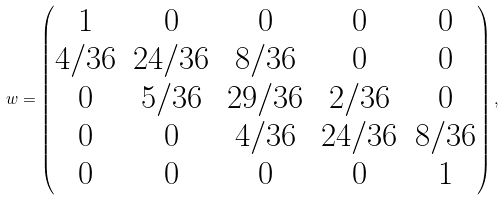<formula> <loc_0><loc_0><loc_500><loc_500>w = \begin{pmatrix} 1 & 0 & 0 & 0 & 0 \\ 4 / 3 6 & 2 4 / 3 6 & 8 / 3 6 & 0 & 0 \\ 0 & 5 / 3 6 & 2 9 / 3 6 & 2 / 3 6 & 0 \\ 0 & 0 & 4 / 3 6 & 2 4 / 3 6 & 8 / 3 6 \\ 0 & 0 & 0 & 0 & 1 \end{pmatrix} ,</formula> 